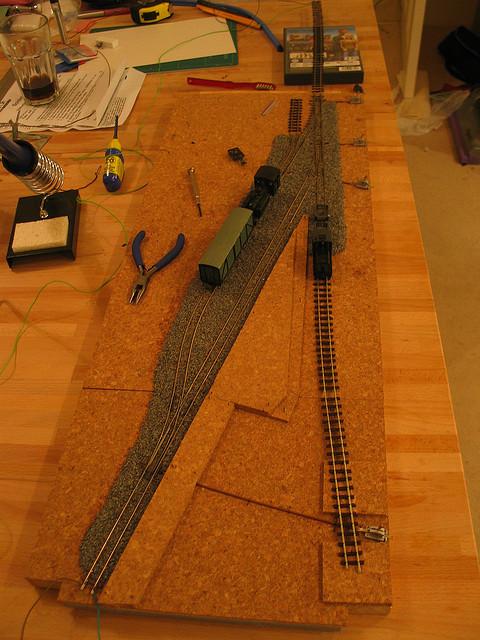Is someone building a railway station for a kid?
Keep it brief. Yes. How full is the glass?
Quick response, please. Almost empty. What makes this picture look 'not real'?
Answer briefly. Toys. Is this a toy?
Give a very brief answer. Yes. What kind of tools are these?
Answer briefly. Pliers. 